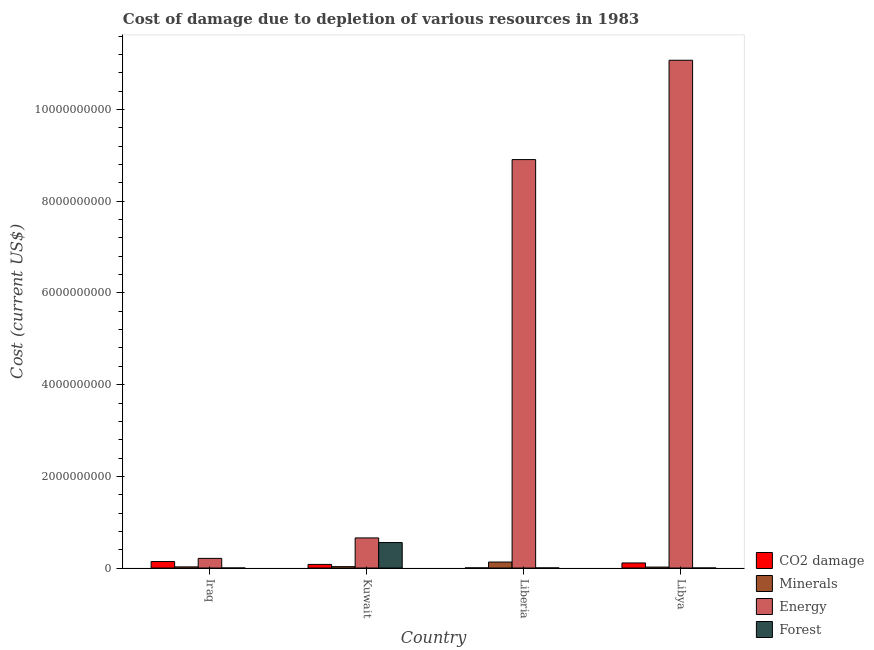How many different coloured bars are there?
Ensure brevity in your answer.  4. Are the number of bars per tick equal to the number of legend labels?
Provide a succinct answer. Yes. Are the number of bars on each tick of the X-axis equal?
Your answer should be very brief. Yes. What is the label of the 4th group of bars from the left?
Offer a very short reply. Libya. What is the cost of damage due to depletion of coal in Liberia?
Provide a short and direct response. 2.60e+06. Across all countries, what is the maximum cost of damage due to depletion of minerals?
Give a very brief answer. 1.31e+08. Across all countries, what is the minimum cost of damage due to depletion of forests?
Ensure brevity in your answer.  1.72e+04. In which country was the cost of damage due to depletion of forests maximum?
Your answer should be very brief. Kuwait. In which country was the cost of damage due to depletion of coal minimum?
Make the answer very short. Liberia. What is the total cost of damage due to depletion of energy in the graph?
Your response must be concise. 2.09e+1. What is the difference between the cost of damage due to depletion of minerals in Liberia and that in Libya?
Offer a very short reply. 1.10e+08. What is the difference between the cost of damage due to depletion of minerals in Liberia and the cost of damage due to depletion of forests in Kuwait?
Your answer should be compact. -4.25e+08. What is the average cost of damage due to depletion of forests per country?
Provide a short and direct response. 1.39e+08. What is the difference between the cost of damage due to depletion of forests and cost of damage due to depletion of energy in Kuwait?
Keep it short and to the point. -1.01e+08. In how many countries, is the cost of damage due to depletion of minerals greater than 10800000000 US$?
Give a very brief answer. 0. What is the ratio of the cost of damage due to depletion of minerals in Liberia to that in Libya?
Provide a succinct answer. 6.3. Is the cost of damage due to depletion of energy in Liberia less than that in Libya?
Give a very brief answer. Yes. Is the difference between the cost of damage due to depletion of forests in Iraq and Liberia greater than the difference between the cost of damage due to depletion of coal in Iraq and Liberia?
Offer a very short reply. No. What is the difference between the highest and the second highest cost of damage due to depletion of minerals?
Provide a short and direct response. 1.00e+08. What is the difference between the highest and the lowest cost of damage due to depletion of energy?
Your answer should be very brief. 1.09e+1. In how many countries, is the cost of damage due to depletion of minerals greater than the average cost of damage due to depletion of minerals taken over all countries?
Provide a succinct answer. 1. Is the sum of the cost of damage due to depletion of energy in Kuwait and Libya greater than the maximum cost of damage due to depletion of coal across all countries?
Keep it short and to the point. Yes. What does the 4th bar from the left in Libya represents?
Offer a terse response. Forest. What does the 1st bar from the right in Liberia represents?
Offer a terse response. Forest. How many bars are there?
Your response must be concise. 16. How many countries are there in the graph?
Provide a succinct answer. 4. What is the difference between two consecutive major ticks on the Y-axis?
Ensure brevity in your answer.  2.00e+09. Are the values on the major ticks of Y-axis written in scientific E-notation?
Your response must be concise. No. Does the graph contain any zero values?
Your response must be concise. No. How many legend labels are there?
Provide a succinct answer. 4. How are the legend labels stacked?
Your response must be concise. Vertical. What is the title of the graph?
Your answer should be compact. Cost of damage due to depletion of various resources in 1983 . Does "Goods and services" appear as one of the legend labels in the graph?
Provide a short and direct response. No. What is the label or title of the X-axis?
Keep it short and to the point. Country. What is the label or title of the Y-axis?
Make the answer very short. Cost (current US$). What is the Cost (current US$) of CO2 damage in Iraq?
Your response must be concise. 1.42e+08. What is the Cost (current US$) in Minerals in Iraq?
Ensure brevity in your answer.  2.49e+07. What is the Cost (current US$) of Energy in Iraq?
Offer a terse response. 2.11e+08. What is the Cost (current US$) in Forest in Iraq?
Your response must be concise. 1.72e+04. What is the Cost (current US$) in CO2 damage in Kuwait?
Your answer should be compact. 7.89e+07. What is the Cost (current US$) in Minerals in Kuwait?
Your response must be concise. 3.02e+07. What is the Cost (current US$) in Energy in Kuwait?
Provide a succinct answer. 6.57e+08. What is the Cost (current US$) of Forest in Kuwait?
Your answer should be very brief. 5.56e+08. What is the Cost (current US$) of CO2 damage in Liberia?
Offer a very short reply. 2.60e+06. What is the Cost (current US$) of Minerals in Liberia?
Keep it short and to the point. 1.31e+08. What is the Cost (current US$) of Energy in Liberia?
Your answer should be compact. 8.91e+09. What is the Cost (current US$) in Forest in Liberia?
Give a very brief answer. 1.80e+06. What is the Cost (current US$) of CO2 damage in Libya?
Your answer should be very brief. 1.11e+08. What is the Cost (current US$) in Minerals in Libya?
Provide a succinct answer. 2.07e+07. What is the Cost (current US$) of Energy in Libya?
Offer a terse response. 1.11e+1. What is the Cost (current US$) in Forest in Libya?
Provide a short and direct response. 4.83e+05. Across all countries, what is the maximum Cost (current US$) in CO2 damage?
Give a very brief answer. 1.42e+08. Across all countries, what is the maximum Cost (current US$) in Minerals?
Provide a succinct answer. 1.31e+08. Across all countries, what is the maximum Cost (current US$) in Energy?
Give a very brief answer. 1.11e+1. Across all countries, what is the maximum Cost (current US$) in Forest?
Your answer should be very brief. 5.56e+08. Across all countries, what is the minimum Cost (current US$) in CO2 damage?
Provide a succinct answer. 2.60e+06. Across all countries, what is the minimum Cost (current US$) of Minerals?
Your answer should be compact. 2.07e+07. Across all countries, what is the minimum Cost (current US$) in Energy?
Provide a succinct answer. 2.11e+08. Across all countries, what is the minimum Cost (current US$) of Forest?
Ensure brevity in your answer.  1.72e+04. What is the total Cost (current US$) of CO2 damage in the graph?
Offer a terse response. 3.34e+08. What is the total Cost (current US$) of Minerals in the graph?
Keep it short and to the point. 2.07e+08. What is the total Cost (current US$) of Energy in the graph?
Your response must be concise. 2.09e+1. What is the total Cost (current US$) of Forest in the graph?
Provide a short and direct response. 5.58e+08. What is the difference between the Cost (current US$) in CO2 damage in Iraq and that in Kuwait?
Offer a very short reply. 6.26e+07. What is the difference between the Cost (current US$) in Minerals in Iraq and that in Kuwait?
Provide a succinct answer. -5.37e+06. What is the difference between the Cost (current US$) of Energy in Iraq and that in Kuwait?
Offer a terse response. -4.46e+08. What is the difference between the Cost (current US$) of Forest in Iraq and that in Kuwait?
Provide a succinct answer. -5.56e+08. What is the difference between the Cost (current US$) of CO2 damage in Iraq and that in Liberia?
Provide a short and direct response. 1.39e+08. What is the difference between the Cost (current US$) in Minerals in Iraq and that in Liberia?
Ensure brevity in your answer.  -1.06e+08. What is the difference between the Cost (current US$) in Energy in Iraq and that in Liberia?
Make the answer very short. -8.70e+09. What is the difference between the Cost (current US$) in Forest in Iraq and that in Liberia?
Your answer should be very brief. -1.78e+06. What is the difference between the Cost (current US$) of CO2 damage in Iraq and that in Libya?
Provide a succinct answer. 3.04e+07. What is the difference between the Cost (current US$) of Minerals in Iraq and that in Libya?
Keep it short and to the point. 4.14e+06. What is the difference between the Cost (current US$) in Energy in Iraq and that in Libya?
Your answer should be very brief. -1.09e+1. What is the difference between the Cost (current US$) of Forest in Iraq and that in Libya?
Offer a very short reply. -4.66e+05. What is the difference between the Cost (current US$) in CO2 damage in Kuwait and that in Liberia?
Give a very brief answer. 7.63e+07. What is the difference between the Cost (current US$) in Minerals in Kuwait and that in Liberia?
Keep it short and to the point. -1.00e+08. What is the difference between the Cost (current US$) in Energy in Kuwait and that in Liberia?
Your answer should be very brief. -8.25e+09. What is the difference between the Cost (current US$) in Forest in Kuwait and that in Liberia?
Offer a very short reply. 5.54e+08. What is the difference between the Cost (current US$) in CO2 damage in Kuwait and that in Libya?
Provide a short and direct response. -3.22e+07. What is the difference between the Cost (current US$) of Minerals in Kuwait and that in Libya?
Provide a succinct answer. 9.51e+06. What is the difference between the Cost (current US$) of Energy in Kuwait and that in Libya?
Ensure brevity in your answer.  -1.04e+1. What is the difference between the Cost (current US$) in Forest in Kuwait and that in Libya?
Give a very brief answer. 5.55e+08. What is the difference between the Cost (current US$) of CO2 damage in Liberia and that in Libya?
Give a very brief answer. -1.08e+08. What is the difference between the Cost (current US$) in Minerals in Liberia and that in Libya?
Make the answer very short. 1.10e+08. What is the difference between the Cost (current US$) of Energy in Liberia and that in Libya?
Your answer should be compact. -2.17e+09. What is the difference between the Cost (current US$) in Forest in Liberia and that in Libya?
Make the answer very short. 1.31e+06. What is the difference between the Cost (current US$) of CO2 damage in Iraq and the Cost (current US$) of Minerals in Kuwait?
Your answer should be very brief. 1.11e+08. What is the difference between the Cost (current US$) in CO2 damage in Iraq and the Cost (current US$) in Energy in Kuwait?
Offer a very short reply. -5.15e+08. What is the difference between the Cost (current US$) in CO2 damage in Iraq and the Cost (current US$) in Forest in Kuwait?
Your answer should be compact. -4.14e+08. What is the difference between the Cost (current US$) in Minerals in Iraq and the Cost (current US$) in Energy in Kuwait?
Offer a very short reply. -6.32e+08. What is the difference between the Cost (current US$) of Minerals in Iraq and the Cost (current US$) of Forest in Kuwait?
Your response must be concise. -5.31e+08. What is the difference between the Cost (current US$) of Energy in Iraq and the Cost (current US$) of Forest in Kuwait?
Ensure brevity in your answer.  -3.45e+08. What is the difference between the Cost (current US$) in CO2 damage in Iraq and the Cost (current US$) in Minerals in Liberia?
Make the answer very short. 1.08e+07. What is the difference between the Cost (current US$) in CO2 damage in Iraq and the Cost (current US$) in Energy in Liberia?
Your answer should be very brief. -8.77e+09. What is the difference between the Cost (current US$) of CO2 damage in Iraq and the Cost (current US$) of Forest in Liberia?
Provide a short and direct response. 1.40e+08. What is the difference between the Cost (current US$) in Minerals in Iraq and the Cost (current US$) in Energy in Liberia?
Ensure brevity in your answer.  -8.89e+09. What is the difference between the Cost (current US$) of Minerals in Iraq and the Cost (current US$) of Forest in Liberia?
Your answer should be very brief. 2.31e+07. What is the difference between the Cost (current US$) of Energy in Iraq and the Cost (current US$) of Forest in Liberia?
Give a very brief answer. 2.09e+08. What is the difference between the Cost (current US$) of CO2 damage in Iraq and the Cost (current US$) of Minerals in Libya?
Your answer should be compact. 1.21e+08. What is the difference between the Cost (current US$) of CO2 damage in Iraq and the Cost (current US$) of Energy in Libya?
Offer a very short reply. -1.09e+1. What is the difference between the Cost (current US$) of CO2 damage in Iraq and the Cost (current US$) of Forest in Libya?
Your answer should be very brief. 1.41e+08. What is the difference between the Cost (current US$) of Minerals in Iraq and the Cost (current US$) of Energy in Libya?
Offer a terse response. -1.11e+1. What is the difference between the Cost (current US$) of Minerals in Iraq and the Cost (current US$) of Forest in Libya?
Offer a terse response. 2.44e+07. What is the difference between the Cost (current US$) in Energy in Iraq and the Cost (current US$) in Forest in Libya?
Give a very brief answer. 2.10e+08. What is the difference between the Cost (current US$) in CO2 damage in Kuwait and the Cost (current US$) in Minerals in Liberia?
Your answer should be compact. -5.18e+07. What is the difference between the Cost (current US$) of CO2 damage in Kuwait and the Cost (current US$) of Energy in Liberia?
Your answer should be compact. -8.83e+09. What is the difference between the Cost (current US$) in CO2 damage in Kuwait and the Cost (current US$) in Forest in Liberia?
Provide a short and direct response. 7.71e+07. What is the difference between the Cost (current US$) of Minerals in Kuwait and the Cost (current US$) of Energy in Liberia?
Give a very brief answer. -8.88e+09. What is the difference between the Cost (current US$) of Minerals in Kuwait and the Cost (current US$) of Forest in Liberia?
Your answer should be compact. 2.84e+07. What is the difference between the Cost (current US$) in Energy in Kuwait and the Cost (current US$) in Forest in Liberia?
Provide a succinct answer. 6.55e+08. What is the difference between the Cost (current US$) of CO2 damage in Kuwait and the Cost (current US$) of Minerals in Libya?
Provide a succinct answer. 5.82e+07. What is the difference between the Cost (current US$) in CO2 damage in Kuwait and the Cost (current US$) in Energy in Libya?
Ensure brevity in your answer.  -1.10e+1. What is the difference between the Cost (current US$) of CO2 damage in Kuwait and the Cost (current US$) of Forest in Libya?
Provide a succinct answer. 7.85e+07. What is the difference between the Cost (current US$) of Minerals in Kuwait and the Cost (current US$) of Energy in Libya?
Ensure brevity in your answer.  -1.10e+1. What is the difference between the Cost (current US$) of Minerals in Kuwait and the Cost (current US$) of Forest in Libya?
Make the answer very short. 2.98e+07. What is the difference between the Cost (current US$) of Energy in Kuwait and the Cost (current US$) of Forest in Libya?
Your response must be concise. 6.56e+08. What is the difference between the Cost (current US$) of CO2 damage in Liberia and the Cost (current US$) of Minerals in Libya?
Offer a very short reply. -1.81e+07. What is the difference between the Cost (current US$) in CO2 damage in Liberia and the Cost (current US$) in Energy in Libya?
Offer a terse response. -1.11e+1. What is the difference between the Cost (current US$) of CO2 damage in Liberia and the Cost (current US$) of Forest in Libya?
Your answer should be compact. 2.12e+06. What is the difference between the Cost (current US$) of Minerals in Liberia and the Cost (current US$) of Energy in Libya?
Offer a terse response. -1.09e+1. What is the difference between the Cost (current US$) of Minerals in Liberia and the Cost (current US$) of Forest in Libya?
Provide a succinct answer. 1.30e+08. What is the difference between the Cost (current US$) in Energy in Liberia and the Cost (current US$) in Forest in Libya?
Give a very brief answer. 8.91e+09. What is the average Cost (current US$) of CO2 damage per country?
Provide a succinct answer. 8.35e+07. What is the average Cost (current US$) of Minerals per country?
Your answer should be very brief. 5.16e+07. What is the average Cost (current US$) of Energy per country?
Provide a succinct answer. 5.21e+09. What is the average Cost (current US$) of Forest per country?
Provide a succinct answer. 1.39e+08. What is the difference between the Cost (current US$) in CO2 damage and Cost (current US$) in Minerals in Iraq?
Offer a very short reply. 1.17e+08. What is the difference between the Cost (current US$) of CO2 damage and Cost (current US$) of Energy in Iraq?
Ensure brevity in your answer.  -6.90e+07. What is the difference between the Cost (current US$) in CO2 damage and Cost (current US$) in Forest in Iraq?
Your answer should be very brief. 1.42e+08. What is the difference between the Cost (current US$) of Minerals and Cost (current US$) of Energy in Iraq?
Make the answer very short. -1.86e+08. What is the difference between the Cost (current US$) in Minerals and Cost (current US$) in Forest in Iraq?
Your answer should be very brief. 2.49e+07. What is the difference between the Cost (current US$) of Energy and Cost (current US$) of Forest in Iraq?
Offer a terse response. 2.10e+08. What is the difference between the Cost (current US$) of CO2 damage and Cost (current US$) of Minerals in Kuwait?
Provide a succinct answer. 4.87e+07. What is the difference between the Cost (current US$) of CO2 damage and Cost (current US$) of Energy in Kuwait?
Your answer should be compact. -5.78e+08. What is the difference between the Cost (current US$) of CO2 damage and Cost (current US$) of Forest in Kuwait?
Make the answer very short. -4.77e+08. What is the difference between the Cost (current US$) of Minerals and Cost (current US$) of Energy in Kuwait?
Offer a very short reply. -6.26e+08. What is the difference between the Cost (current US$) of Minerals and Cost (current US$) of Forest in Kuwait?
Keep it short and to the point. -5.25e+08. What is the difference between the Cost (current US$) in Energy and Cost (current US$) in Forest in Kuwait?
Offer a terse response. 1.01e+08. What is the difference between the Cost (current US$) of CO2 damage and Cost (current US$) of Minerals in Liberia?
Provide a succinct answer. -1.28e+08. What is the difference between the Cost (current US$) in CO2 damage and Cost (current US$) in Energy in Liberia?
Make the answer very short. -8.91e+09. What is the difference between the Cost (current US$) in CO2 damage and Cost (current US$) in Forest in Liberia?
Your answer should be very brief. 8.01e+05. What is the difference between the Cost (current US$) in Minerals and Cost (current US$) in Energy in Liberia?
Your response must be concise. -8.78e+09. What is the difference between the Cost (current US$) in Minerals and Cost (current US$) in Forest in Liberia?
Give a very brief answer. 1.29e+08. What is the difference between the Cost (current US$) of Energy and Cost (current US$) of Forest in Liberia?
Offer a very short reply. 8.91e+09. What is the difference between the Cost (current US$) in CO2 damage and Cost (current US$) in Minerals in Libya?
Your response must be concise. 9.04e+07. What is the difference between the Cost (current US$) in CO2 damage and Cost (current US$) in Energy in Libya?
Ensure brevity in your answer.  -1.10e+1. What is the difference between the Cost (current US$) of CO2 damage and Cost (current US$) of Forest in Libya?
Offer a very short reply. 1.11e+08. What is the difference between the Cost (current US$) of Minerals and Cost (current US$) of Energy in Libya?
Provide a succinct answer. -1.11e+1. What is the difference between the Cost (current US$) of Minerals and Cost (current US$) of Forest in Libya?
Your answer should be compact. 2.03e+07. What is the difference between the Cost (current US$) of Energy and Cost (current US$) of Forest in Libya?
Offer a terse response. 1.11e+1. What is the ratio of the Cost (current US$) of CO2 damage in Iraq to that in Kuwait?
Offer a very short reply. 1.79. What is the ratio of the Cost (current US$) in Minerals in Iraq to that in Kuwait?
Your answer should be compact. 0.82. What is the ratio of the Cost (current US$) of Energy in Iraq to that in Kuwait?
Your response must be concise. 0.32. What is the ratio of the Cost (current US$) of Forest in Iraq to that in Kuwait?
Your answer should be very brief. 0. What is the ratio of the Cost (current US$) in CO2 damage in Iraq to that in Liberia?
Offer a terse response. 54.47. What is the ratio of the Cost (current US$) of Minerals in Iraq to that in Liberia?
Provide a succinct answer. 0.19. What is the ratio of the Cost (current US$) of Energy in Iraq to that in Liberia?
Offer a terse response. 0.02. What is the ratio of the Cost (current US$) of Forest in Iraq to that in Liberia?
Provide a succinct answer. 0.01. What is the ratio of the Cost (current US$) of CO2 damage in Iraq to that in Libya?
Provide a short and direct response. 1.27. What is the ratio of the Cost (current US$) in Minerals in Iraq to that in Libya?
Offer a very short reply. 1.2. What is the ratio of the Cost (current US$) in Energy in Iraq to that in Libya?
Offer a terse response. 0.02. What is the ratio of the Cost (current US$) of Forest in Iraq to that in Libya?
Give a very brief answer. 0.04. What is the ratio of the Cost (current US$) in CO2 damage in Kuwait to that in Liberia?
Ensure brevity in your answer.  30.38. What is the ratio of the Cost (current US$) of Minerals in Kuwait to that in Liberia?
Provide a succinct answer. 0.23. What is the ratio of the Cost (current US$) of Energy in Kuwait to that in Liberia?
Offer a terse response. 0.07. What is the ratio of the Cost (current US$) in Forest in Kuwait to that in Liberia?
Your answer should be compact. 309.06. What is the ratio of the Cost (current US$) of CO2 damage in Kuwait to that in Libya?
Provide a succinct answer. 0.71. What is the ratio of the Cost (current US$) in Minerals in Kuwait to that in Libya?
Provide a short and direct response. 1.46. What is the ratio of the Cost (current US$) of Energy in Kuwait to that in Libya?
Your answer should be compact. 0.06. What is the ratio of the Cost (current US$) in Forest in Kuwait to that in Libya?
Your answer should be very brief. 1149.93. What is the ratio of the Cost (current US$) of CO2 damage in Liberia to that in Libya?
Your response must be concise. 0.02. What is the ratio of the Cost (current US$) of Minerals in Liberia to that in Libya?
Offer a very short reply. 6.3. What is the ratio of the Cost (current US$) of Energy in Liberia to that in Libya?
Provide a short and direct response. 0.8. What is the ratio of the Cost (current US$) of Forest in Liberia to that in Libya?
Offer a very short reply. 3.72. What is the difference between the highest and the second highest Cost (current US$) in CO2 damage?
Offer a terse response. 3.04e+07. What is the difference between the highest and the second highest Cost (current US$) of Minerals?
Your answer should be very brief. 1.00e+08. What is the difference between the highest and the second highest Cost (current US$) in Energy?
Make the answer very short. 2.17e+09. What is the difference between the highest and the second highest Cost (current US$) in Forest?
Your response must be concise. 5.54e+08. What is the difference between the highest and the lowest Cost (current US$) of CO2 damage?
Make the answer very short. 1.39e+08. What is the difference between the highest and the lowest Cost (current US$) of Minerals?
Your response must be concise. 1.10e+08. What is the difference between the highest and the lowest Cost (current US$) of Energy?
Your response must be concise. 1.09e+1. What is the difference between the highest and the lowest Cost (current US$) of Forest?
Your answer should be compact. 5.56e+08. 